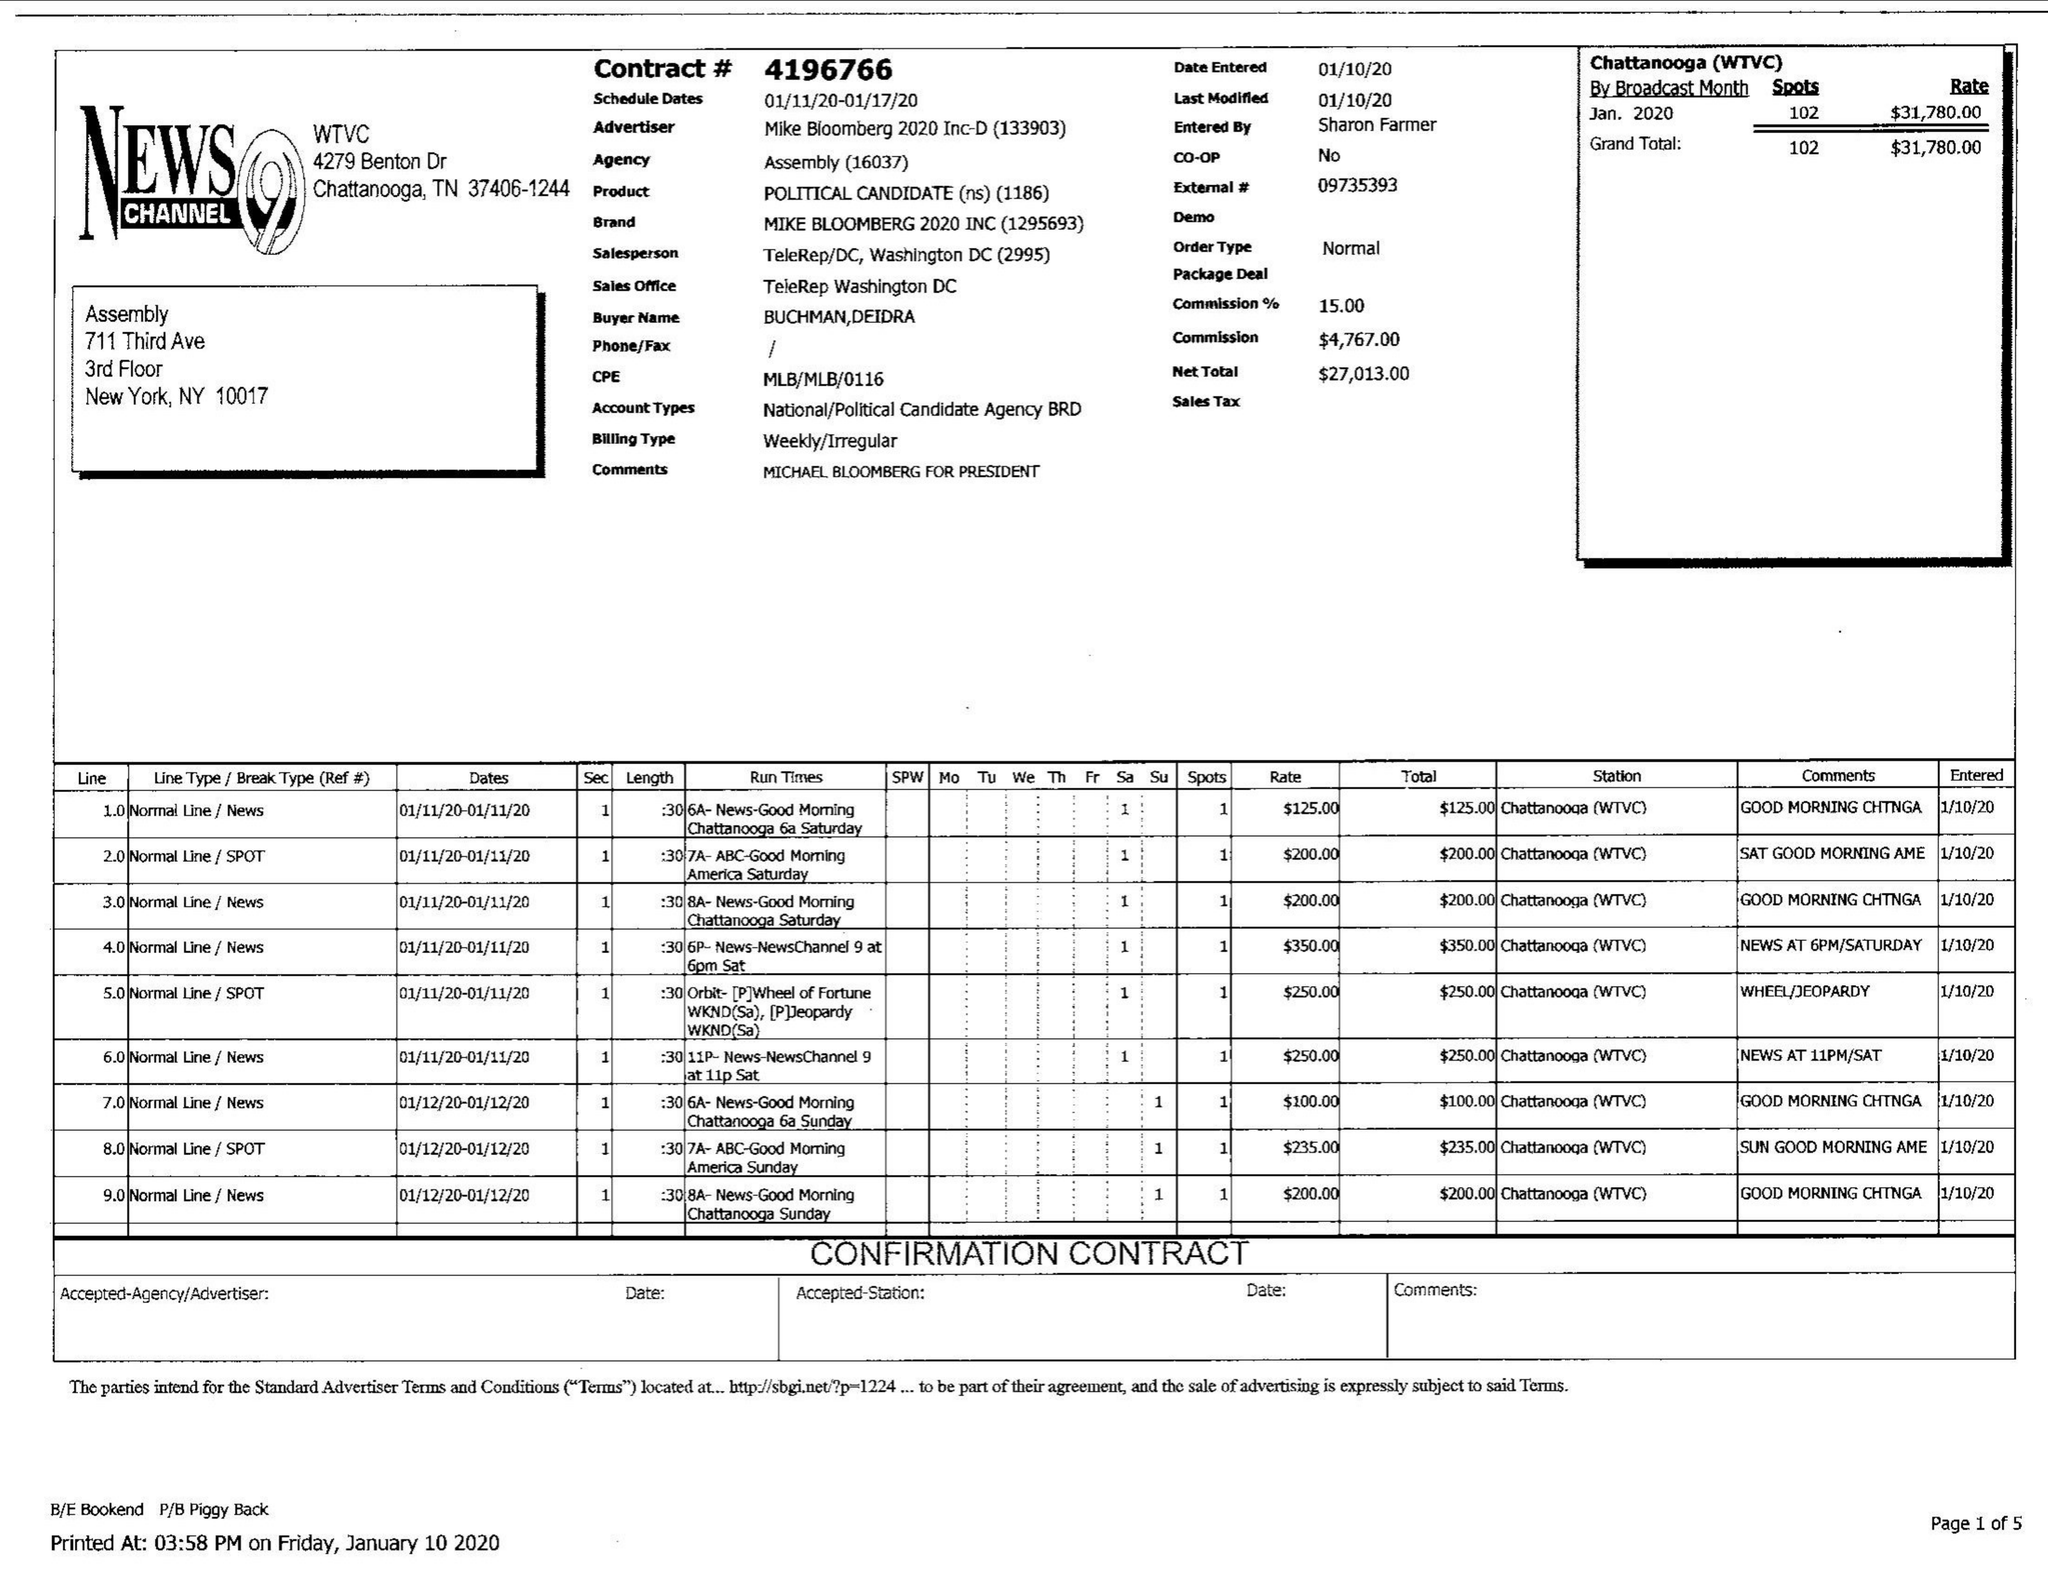What is the value for the flight_to?
Answer the question using a single word or phrase. 01/17/20 